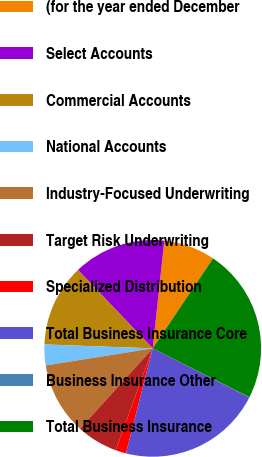<chart> <loc_0><loc_0><loc_500><loc_500><pie_chart><fcel>(for the year ended December<fcel>Select Accounts<fcel>Commercial Accounts<fcel>National Accounts<fcel>Industry-Focused Underwriting<fcel>Target Risk Underwriting<fcel>Specialized Distribution<fcel>Total Business Insurance Core<fcel>Business Insurance Other<fcel>Total Business Insurance<nl><fcel>7.7%<fcel>13.83%<fcel>12.3%<fcel>3.1%<fcel>10.77%<fcel>6.17%<fcel>1.57%<fcel>21.5%<fcel>0.04%<fcel>23.03%<nl></chart> 